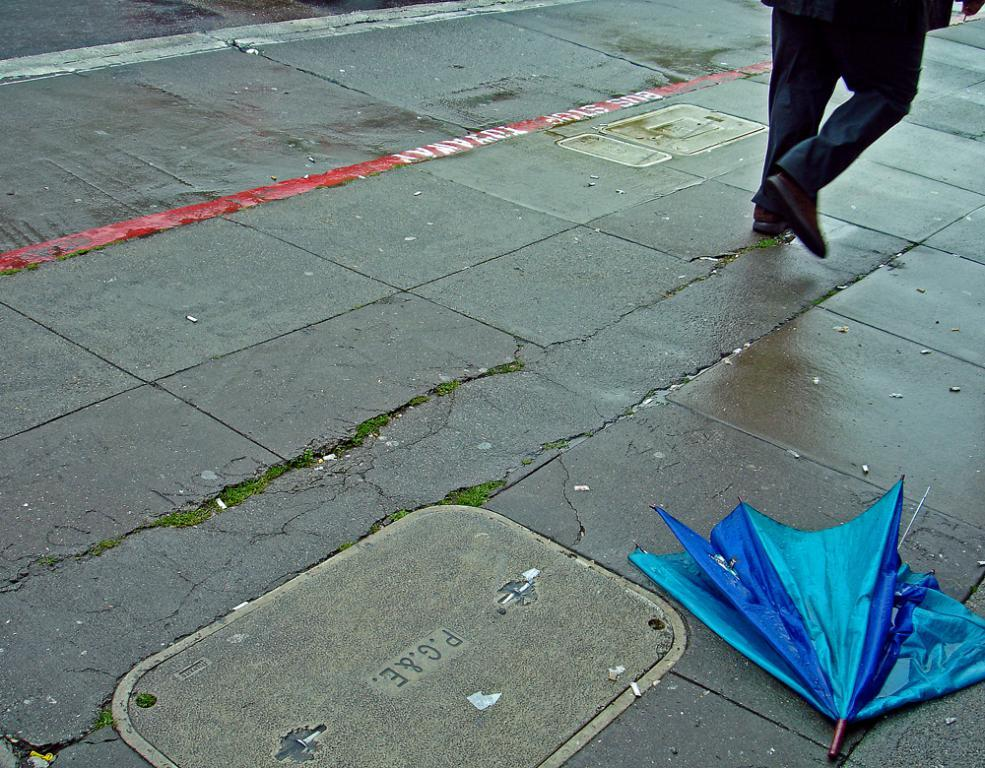What object is on the floor in the bottom right side of the image? There is an umbrella on the floor in the bottom right side of the image. Can you describe the man in the image? There is a man at the top side of the image. What type of tree can be seen growing in the image? There is no tree present in the image; it only features an umbrella on the floor and a man at the top side. What appliance is being used by the man in the image? There is no appliance visible in the image; the man is simply present at the top side. 